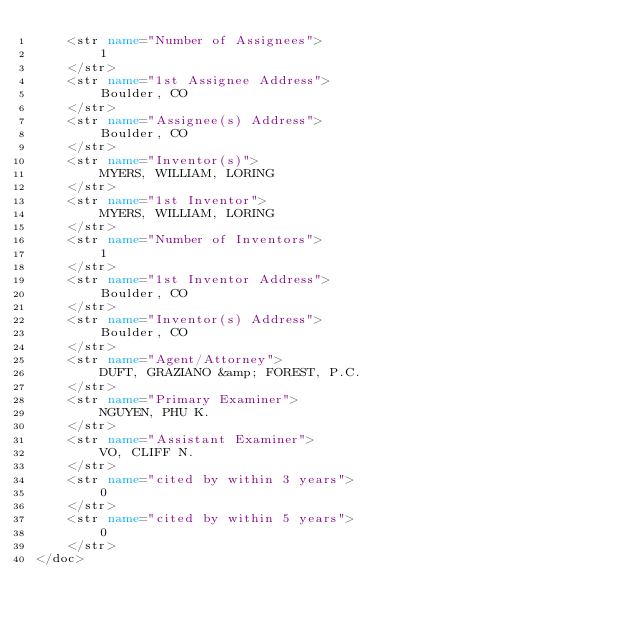Convert code to text. <code><loc_0><loc_0><loc_500><loc_500><_XML_>	<str name="Number of Assignees">
		1
	</str>
	<str name="1st Assignee Address">
		Boulder, CO
	</str>
	<str name="Assignee(s) Address">
		Boulder, CO
	</str>
	<str name="Inventor(s)">
		MYERS, WILLIAM, LORING
	</str>
	<str name="1st Inventor">
		MYERS, WILLIAM, LORING
	</str>
	<str name="Number of Inventors">
		1
	</str>
	<str name="1st Inventor Address">
		Boulder, CO
	</str>
	<str name="Inventor(s) Address">
		Boulder, CO
	</str>
	<str name="Agent/Attorney">
		DUFT, GRAZIANO &amp; FOREST, P.C.
	</str>
	<str name="Primary Examiner">
		NGUYEN, PHU K.
	</str>
	<str name="Assistant Examiner">
		VO, CLIFF N.
	</str>
	<str name="cited by within 3 years">
		0
	</str>
	<str name="cited by within 5 years">
		0
	</str>
</doc>

</code> 